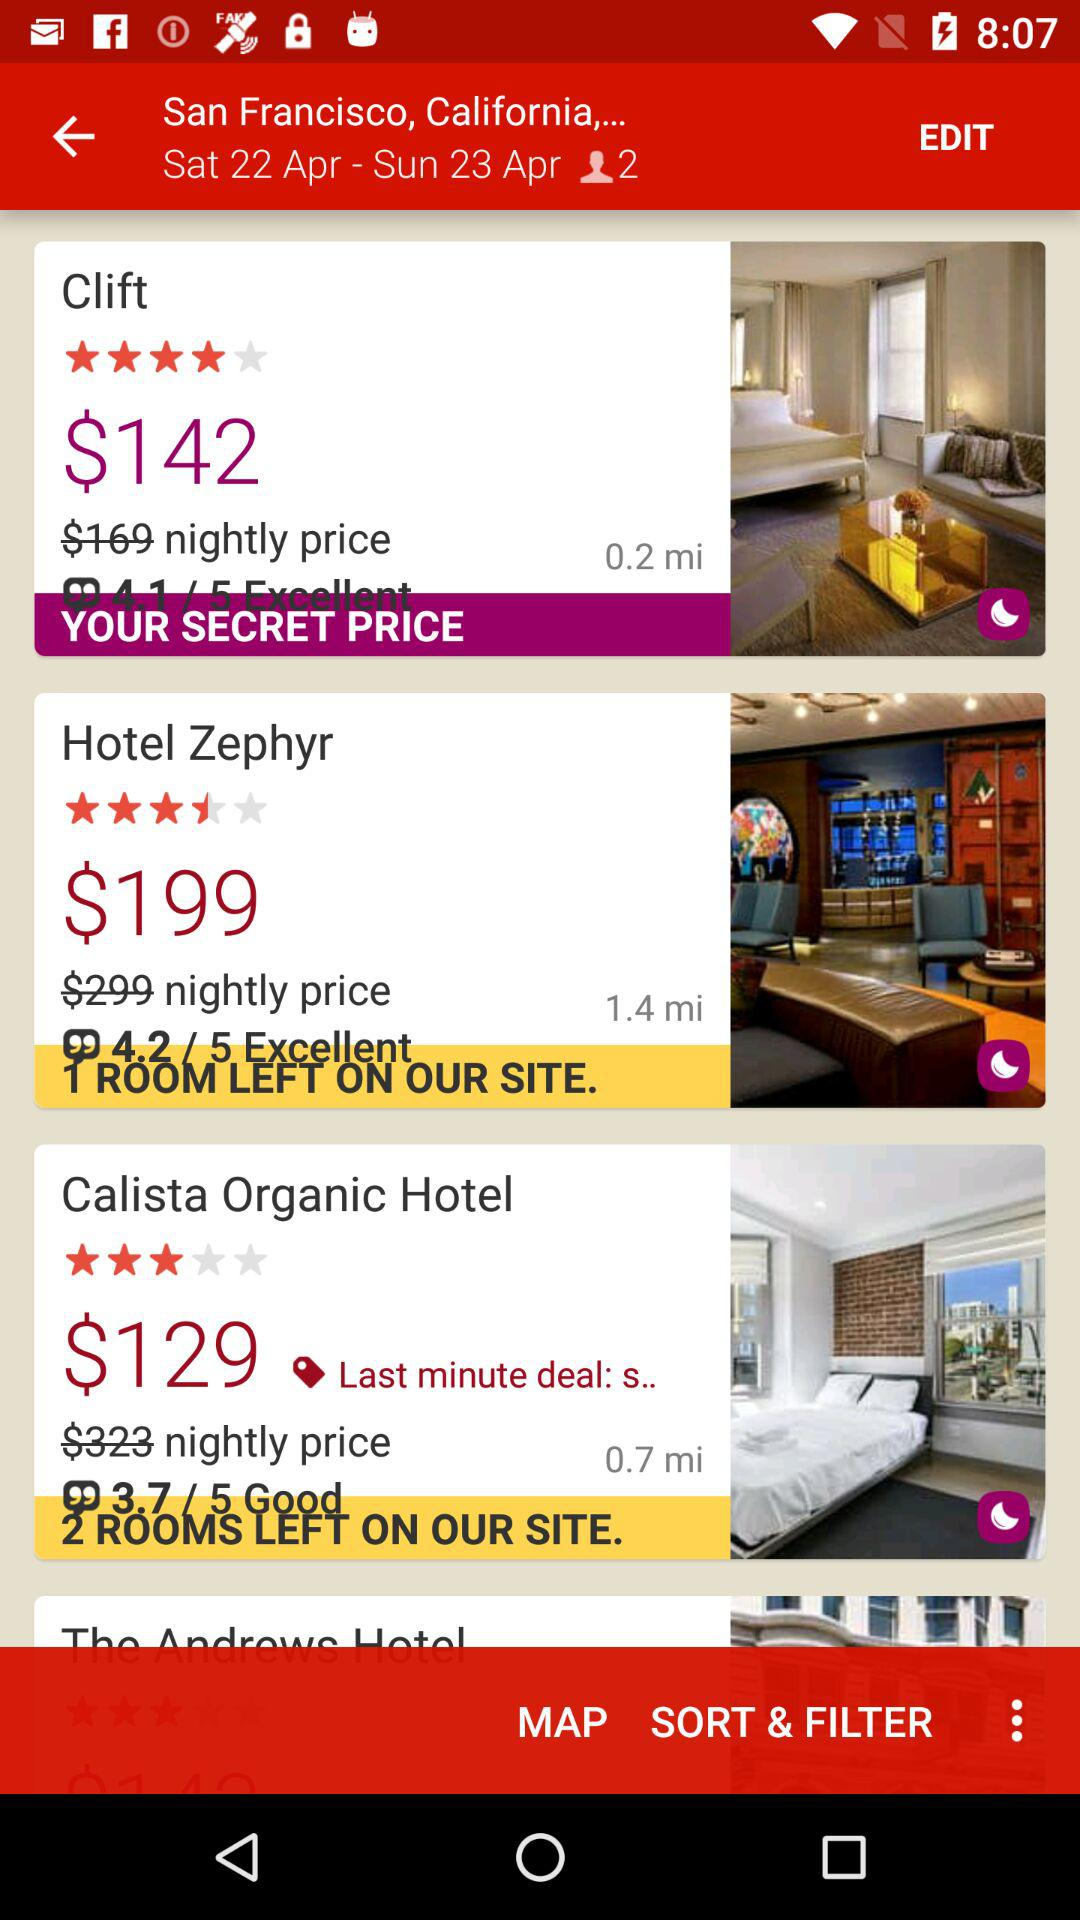Which date range is selected? The date range is between Saturday, April 22 and Sunday, April 23. 